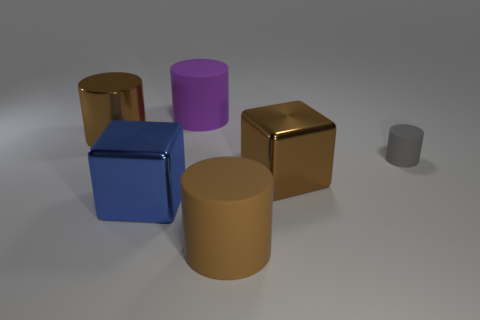What shape is the rubber object that is the same color as the shiny cylinder?
Offer a terse response. Cylinder. How many things are big cylinders behind the blue metallic cube or metallic cylinders?
Provide a succinct answer. 2. There is a brown object that is the same material as the gray object; what is its size?
Offer a terse response. Large. There is a blue shiny object; is its size the same as the matte thing that is behind the small cylinder?
Give a very brief answer. Yes. What color is the large cylinder that is both in front of the purple cylinder and to the right of the large blue cube?
Provide a short and direct response. Brown. What number of things are either rubber things left of the tiny gray cylinder or brown objects that are behind the brown matte cylinder?
Offer a terse response. 4. There is a large matte thing to the left of the matte cylinder in front of the big blue object left of the large purple rubber thing; what color is it?
Provide a short and direct response. Purple. Is there a purple object of the same shape as the large blue metallic object?
Make the answer very short. No. How many brown things are there?
Ensure brevity in your answer.  3. The blue shiny object is what shape?
Your answer should be compact. Cube. 